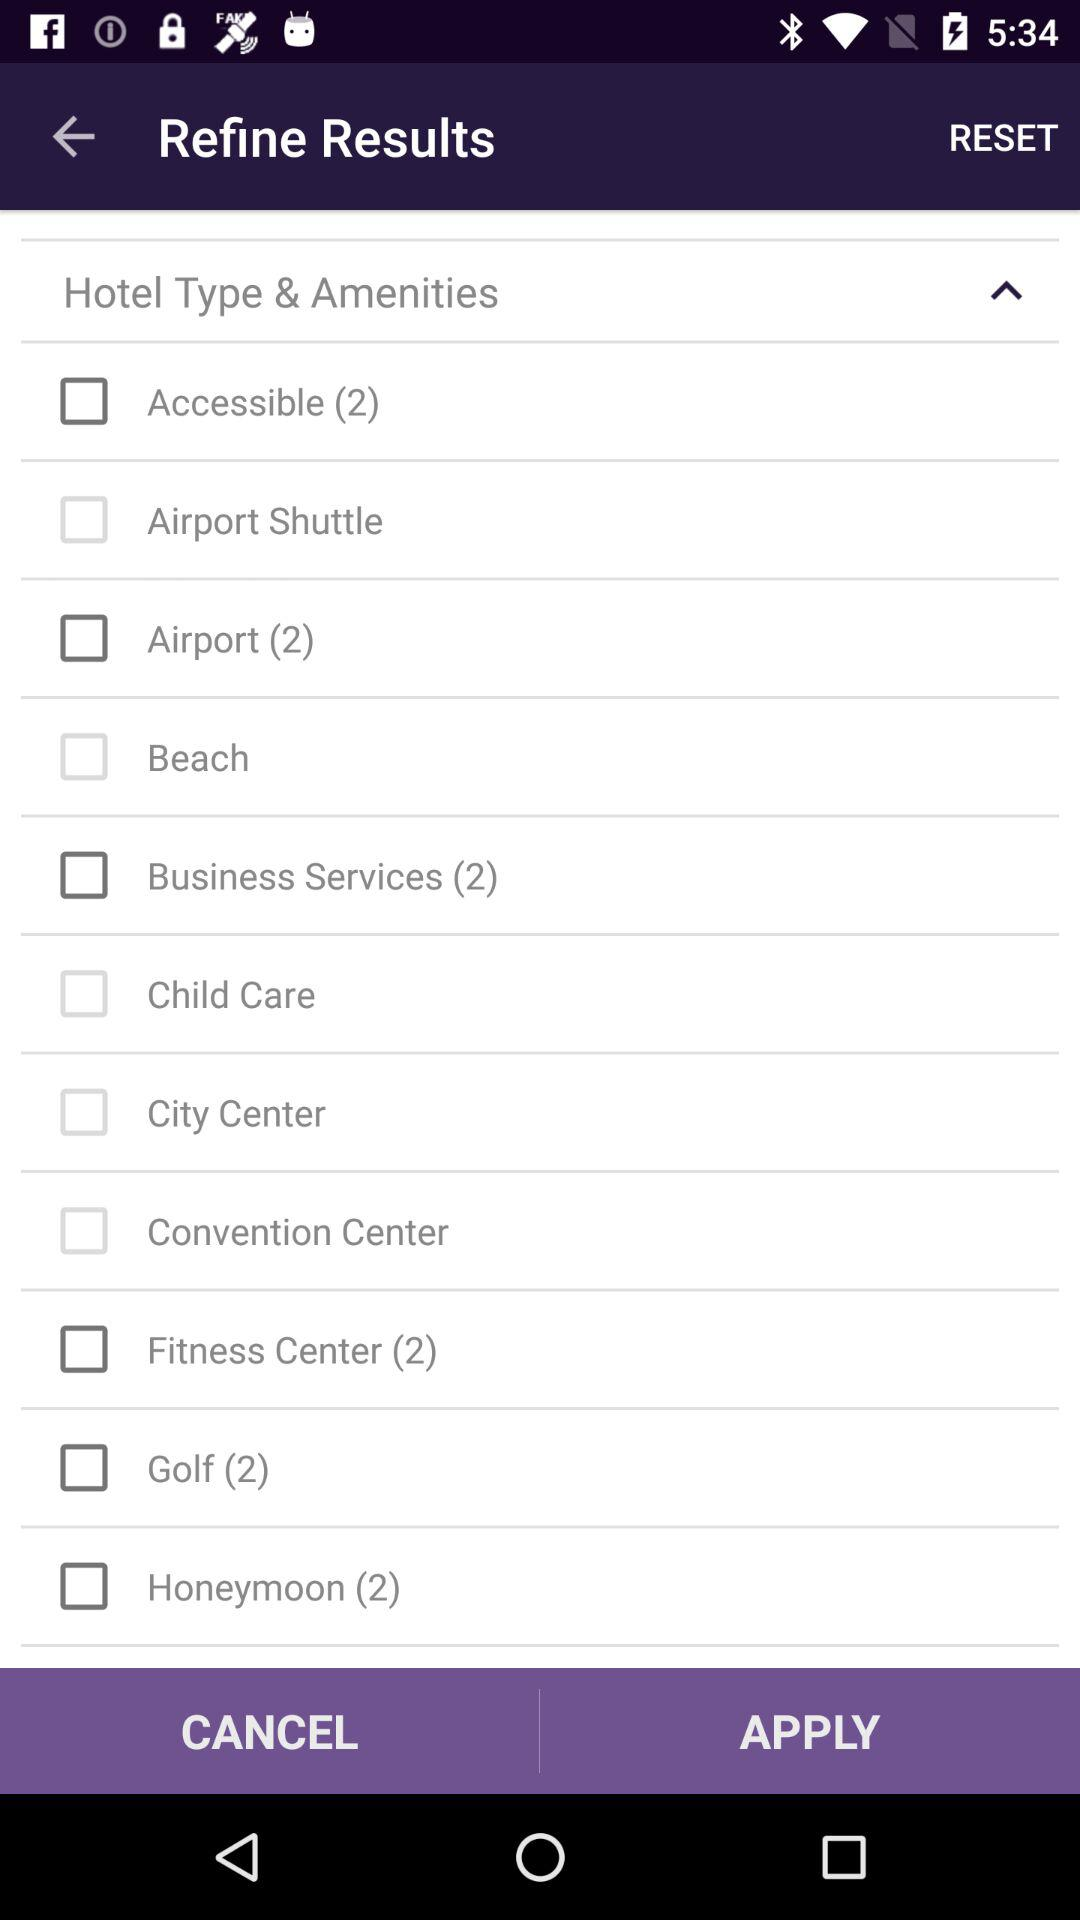What's the status of "Beach"? The status is "off". 